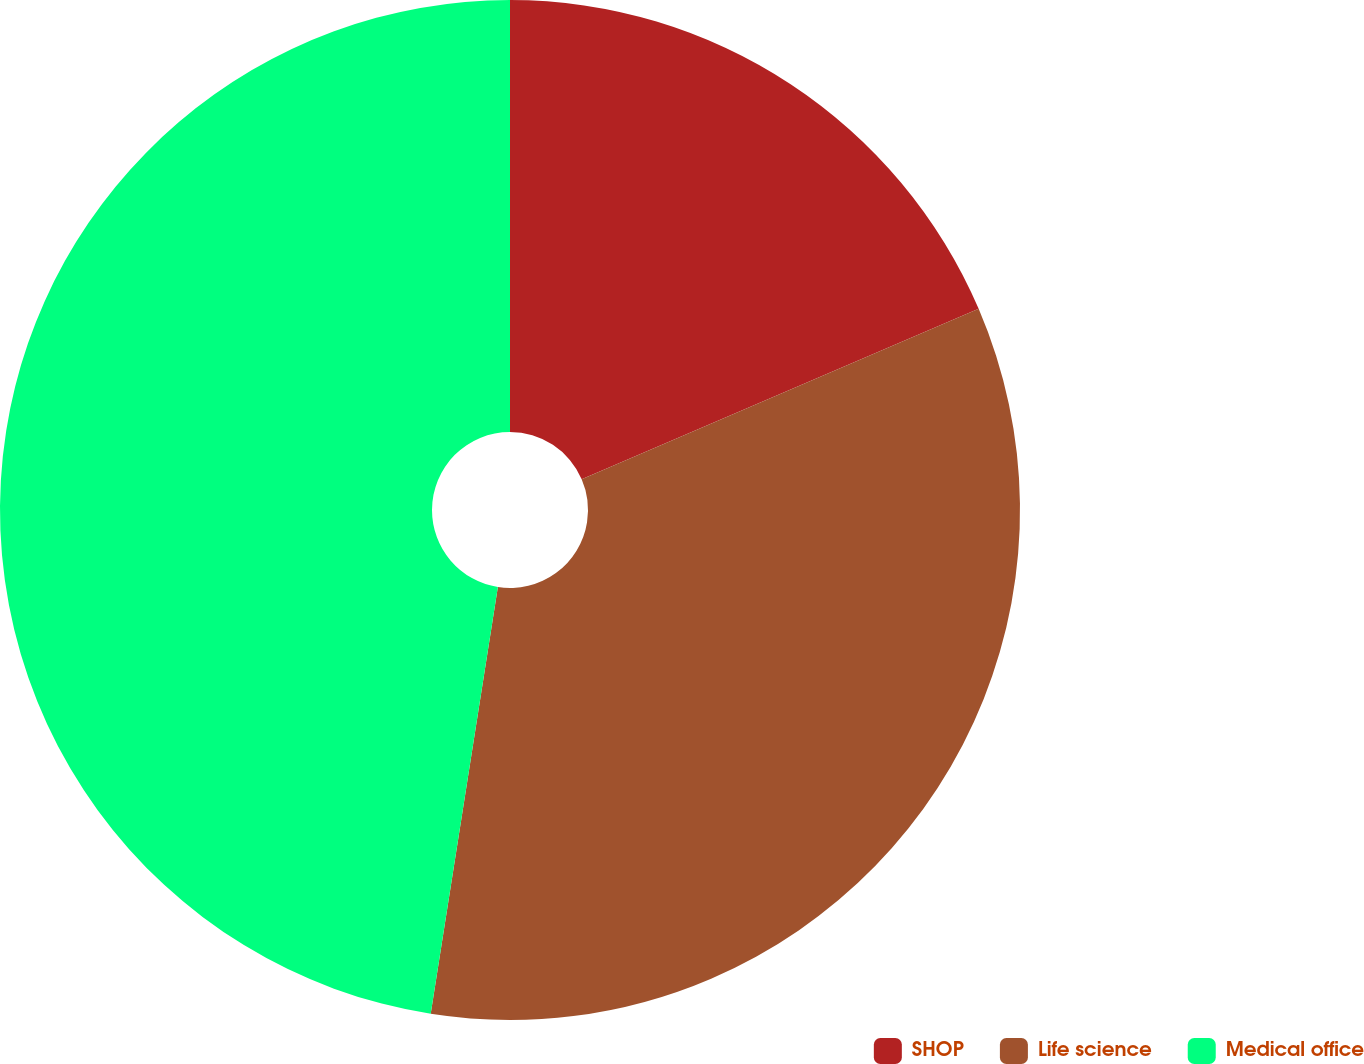Convert chart. <chart><loc_0><loc_0><loc_500><loc_500><pie_chart><fcel>SHOP<fcel>Life science<fcel>Medical office<nl><fcel>18.55%<fcel>33.94%<fcel>47.52%<nl></chart> 